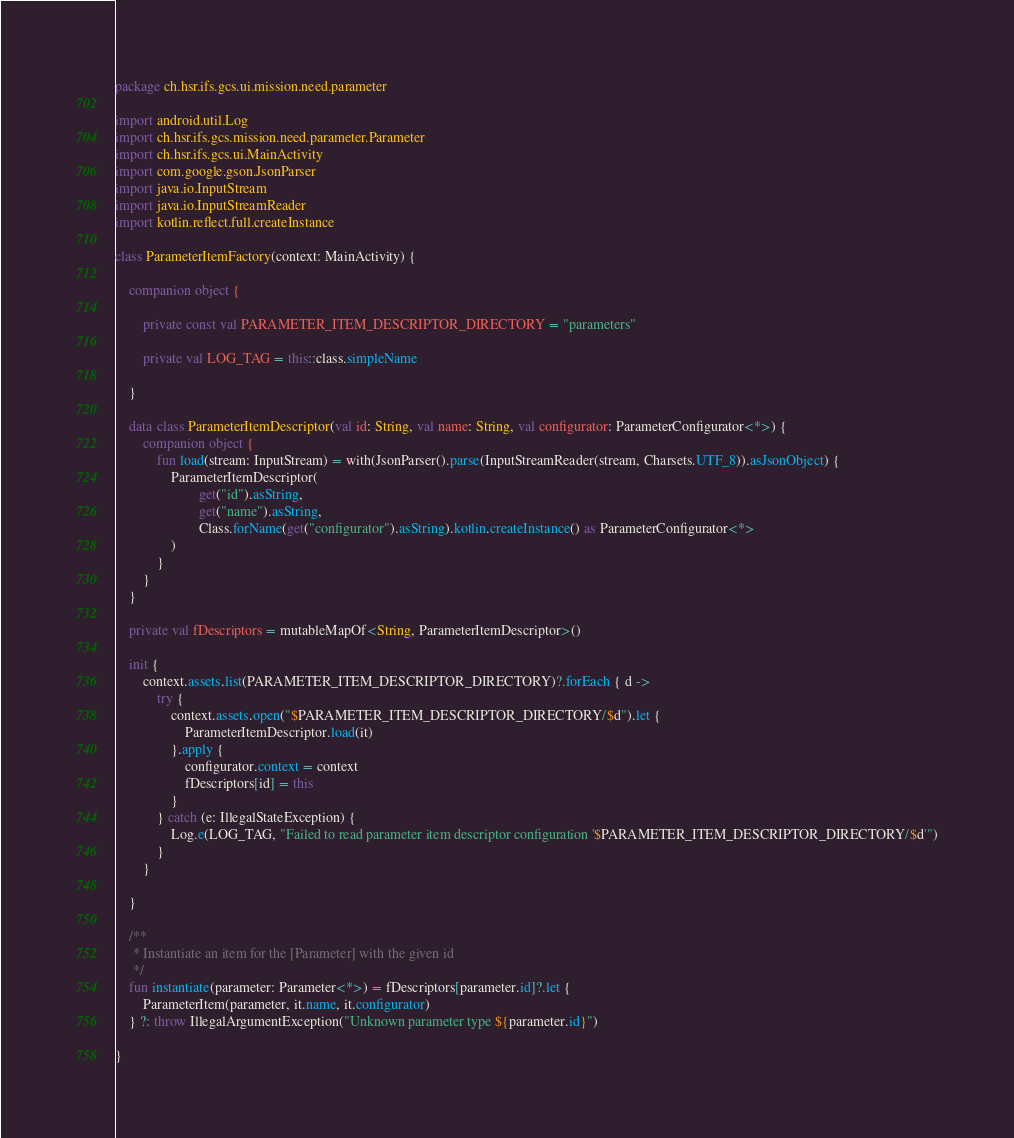<code> <loc_0><loc_0><loc_500><loc_500><_Kotlin_>package ch.hsr.ifs.gcs.ui.mission.need.parameter

import android.util.Log
import ch.hsr.ifs.gcs.mission.need.parameter.Parameter
import ch.hsr.ifs.gcs.ui.MainActivity
import com.google.gson.JsonParser
import java.io.InputStream
import java.io.InputStreamReader
import kotlin.reflect.full.createInstance

class ParameterItemFactory(context: MainActivity) {

    companion object {

        private const val PARAMETER_ITEM_DESCRIPTOR_DIRECTORY = "parameters"

        private val LOG_TAG = this::class.simpleName

    }

    data class ParameterItemDescriptor(val id: String, val name: String, val configurator: ParameterConfigurator<*>) {
        companion object {
            fun load(stream: InputStream) = with(JsonParser().parse(InputStreamReader(stream, Charsets.UTF_8)).asJsonObject) {
                ParameterItemDescriptor(
                        get("id").asString,
                        get("name").asString,
                        Class.forName(get("configurator").asString).kotlin.createInstance() as ParameterConfigurator<*>
                )
            }
        }
    }

    private val fDescriptors = mutableMapOf<String, ParameterItemDescriptor>()

    init {
        context.assets.list(PARAMETER_ITEM_DESCRIPTOR_DIRECTORY)?.forEach { d ->
            try {
                context.assets.open("$PARAMETER_ITEM_DESCRIPTOR_DIRECTORY/$d").let {
                    ParameterItemDescriptor.load(it)
                }.apply {
                    configurator.context = context
                    fDescriptors[id] = this
                }
            } catch (e: IllegalStateException) {
                Log.e(LOG_TAG, "Failed to read parameter item descriptor configuration '$PARAMETER_ITEM_DESCRIPTOR_DIRECTORY/$d'")
            }
        }

    }

    /**
     * Instantiate an item for the [Parameter] with the given id
     */
    fun instantiate(parameter: Parameter<*>) = fDescriptors[parameter.id]?.let {
        ParameterItem(parameter, it.name, it.configurator)
    } ?: throw IllegalArgumentException("Unknown parameter type ${parameter.id}")

}</code> 